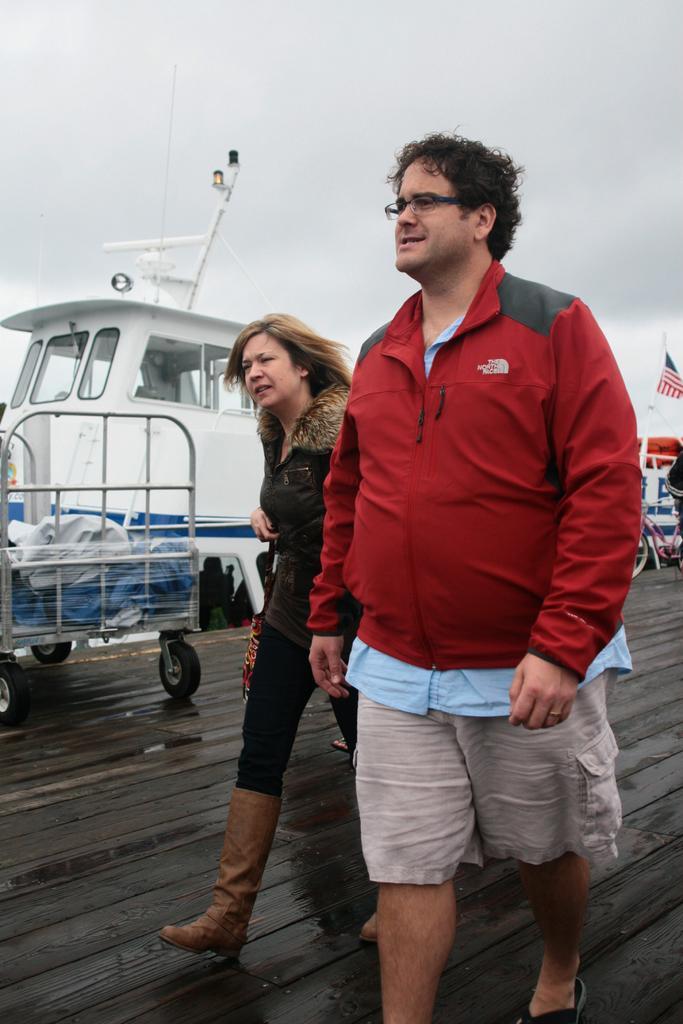How would you summarize this image in a sentence or two? In this image, I can see the man and woman walking. This is a kind of a wheel cart. In the background, I think this is a boat. On the right corner of the image, I can see a flag hanging and a bicycle. This is the sky. 